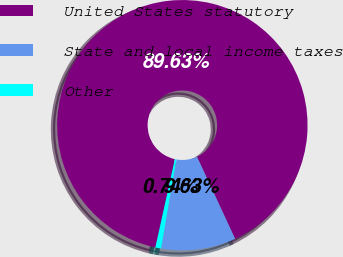<chart> <loc_0><loc_0><loc_500><loc_500><pie_chart><fcel>United States statutory<fcel>State and local income taxes<fcel>Other<nl><fcel>89.63%<fcel>9.63%<fcel>0.74%<nl></chart> 